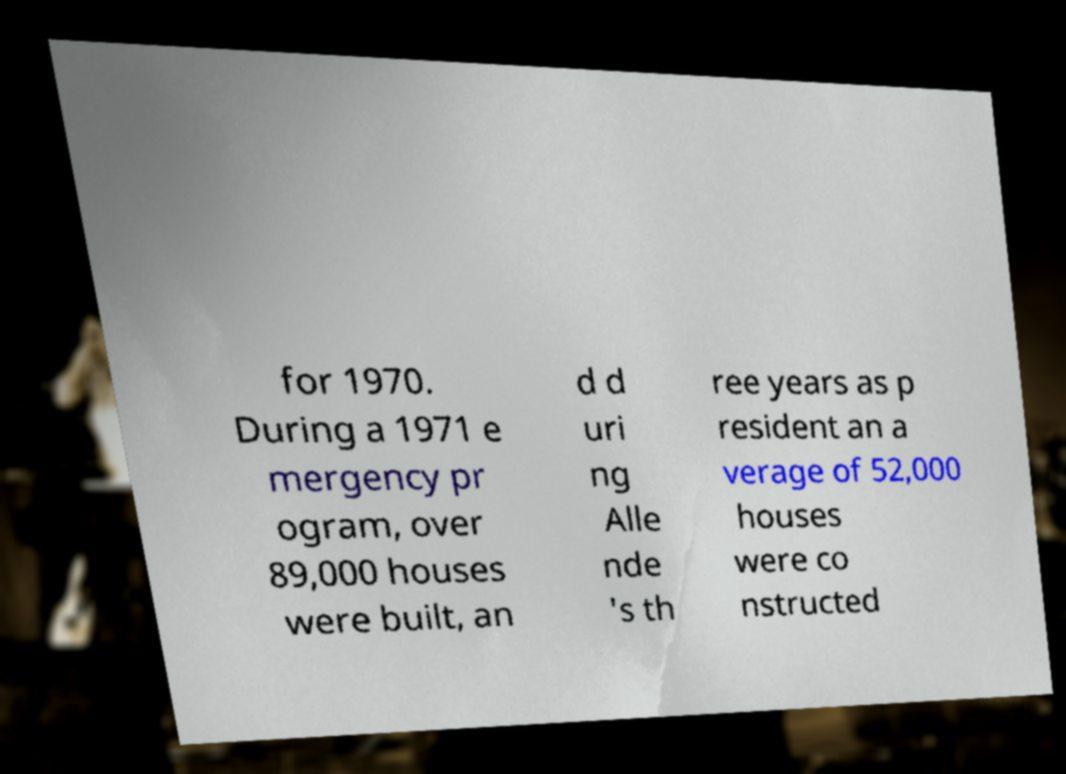For documentation purposes, I need the text within this image transcribed. Could you provide that? for 1970. During a 1971 e mergency pr ogram, over 89,000 houses were built, an d d uri ng Alle nde 's th ree years as p resident an a verage of 52,000 houses were co nstructed 